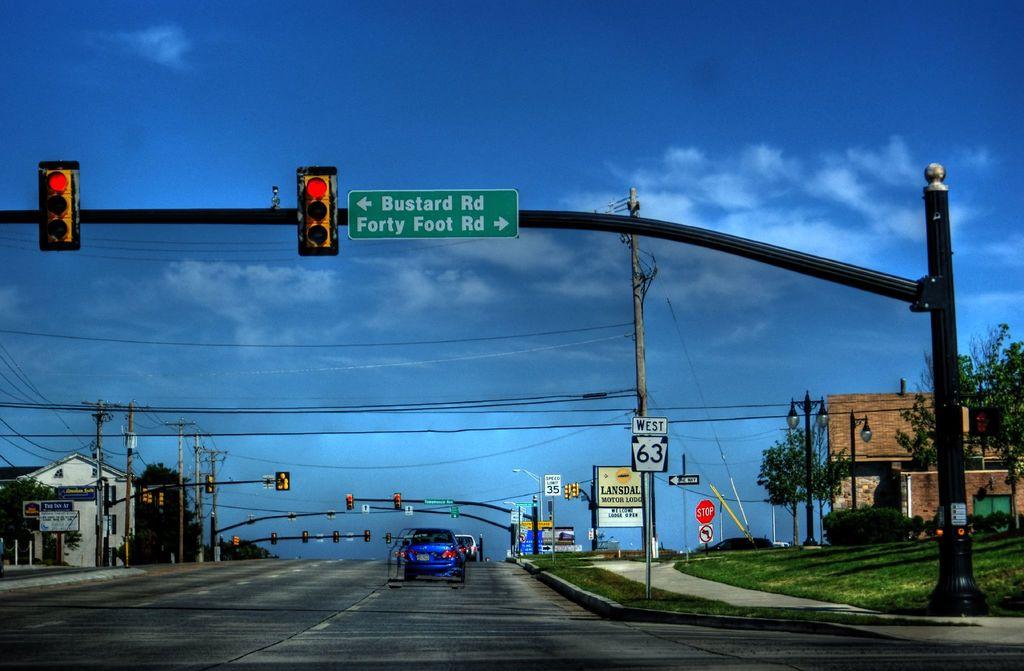What road is on the left ?
Give a very brief answer. Bustard rd. 